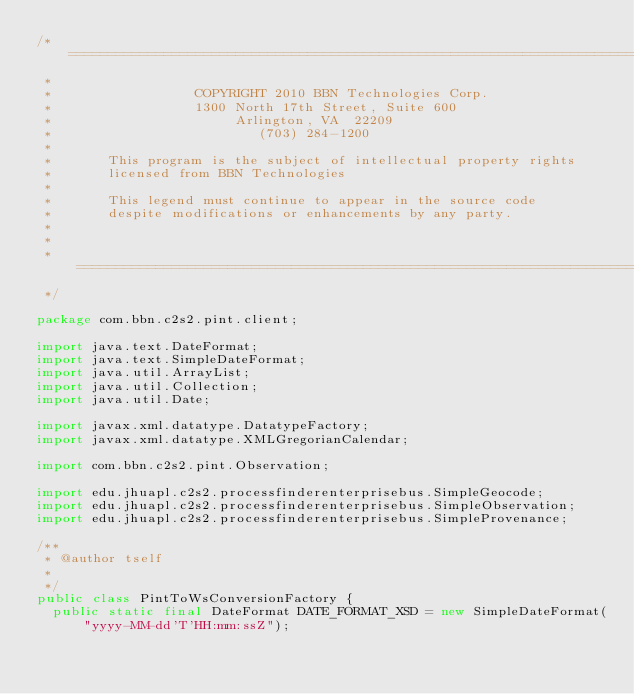<code> <loc_0><loc_0><loc_500><loc_500><_Java_>/* =============================================================================
 *
 *                  COPYRIGHT 2010 BBN Technologies Corp.
 *                  1300 North 17th Street, Suite 600
 *                       Arlington, VA  22209
 *                          (703) 284-1200
 *
 *       This program is the subject of intellectual property rights
 *       licensed from BBN Technologies
 *
 *       This legend must continue to appear in the source code
 *       despite modifications or enhancements by any party.
 *
 *
 * ==============================================================================
 */

package com.bbn.c2s2.pint.client;

import java.text.DateFormat;
import java.text.SimpleDateFormat;
import java.util.ArrayList;
import java.util.Collection;
import java.util.Date;

import javax.xml.datatype.DatatypeFactory;
import javax.xml.datatype.XMLGregorianCalendar;

import com.bbn.c2s2.pint.Observation;

import edu.jhuapl.c2s2.processfinderenterprisebus.SimpleGeocode;
import edu.jhuapl.c2s2.processfinderenterprisebus.SimpleObservation;
import edu.jhuapl.c2s2.processfinderenterprisebus.SimpleProvenance;

/**
 * @author tself
 * 
 */
public class PintToWsConversionFactory {
	public static final DateFormat DATE_FORMAT_XSD = new SimpleDateFormat(
			"yyyy-MM-dd'T'HH:mm:ssZ");
</code> 